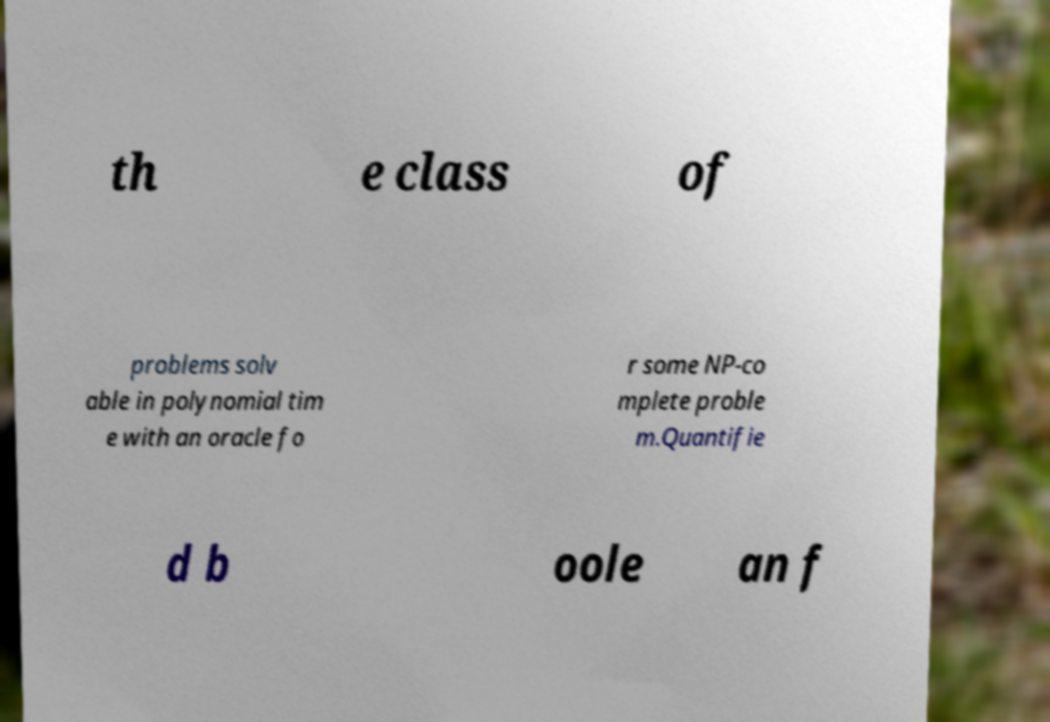There's text embedded in this image that I need extracted. Can you transcribe it verbatim? th e class of problems solv able in polynomial tim e with an oracle fo r some NP-co mplete proble m.Quantifie d b oole an f 